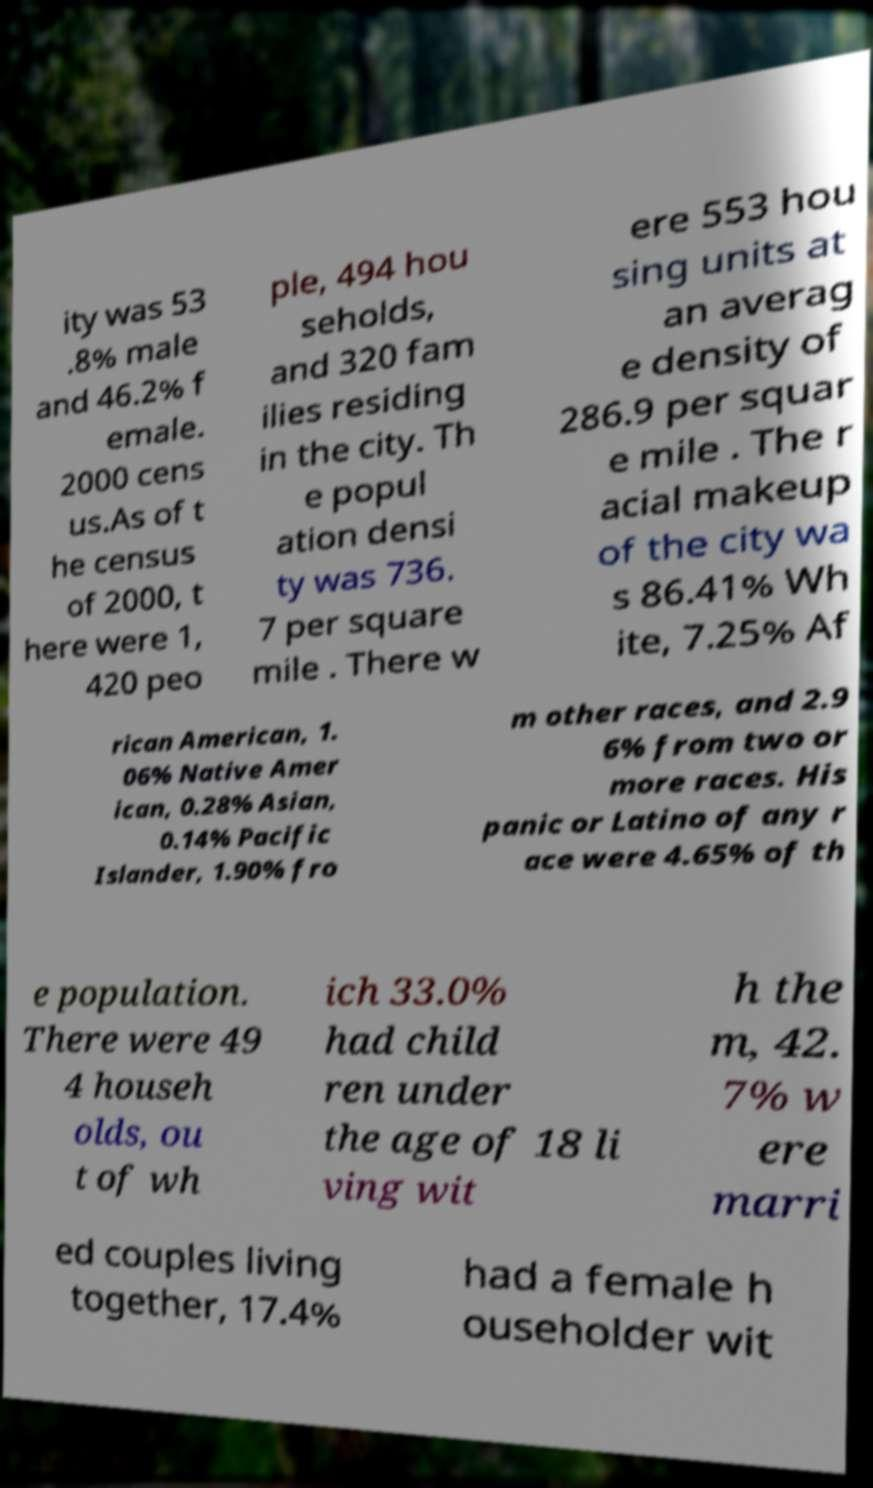Can you accurately transcribe the text from the provided image for me? ity was 53 .8% male and 46.2% f emale. 2000 cens us.As of t he census of 2000, t here were 1, 420 peo ple, 494 hou seholds, and 320 fam ilies residing in the city. Th e popul ation densi ty was 736. 7 per square mile . There w ere 553 hou sing units at an averag e density of 286.9 per squar e mile . The r acial makeup of the city wa s 86.41% Wh ite, 7.25% Af rican American, 1. 06% Native Amer ican, 0.28% Asian, 0.14% Pacific Islander, 1.90% fro m other races, and 2.9 6% from two or more races. His panic or Latino of any r ace were 4.65% of th e population. There were 49 4 househ olds, ou t of wh ich 33.0% had child ren under the age of 18 li ving wit h the m, 42. 7% w ere marri ed couples living together, 17.4% had a female h ouseholder wit 